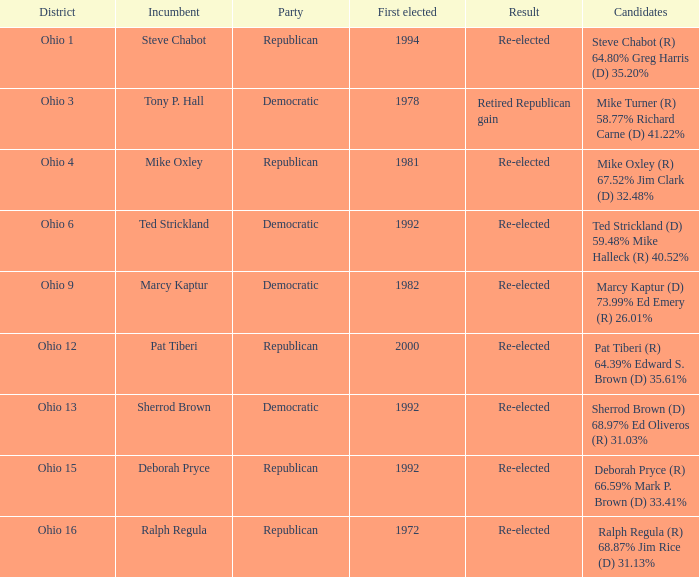Which party was incumbent deborah pryce a member of? Republican. Help me parse the entirety of this table. {'header': ['District', 'Incumbent', 'Party', 'First elected', 'Result', 'Candidates'], 'rows': [['Ohio 1', 'Steve Chabot', 'Republican', '1994', 'Re-elected', 'Steve Chabot (R) 64.80% Greg Harris (D) 35.20%'], ['Ohio 3', 'Tony P. Hall', 'Democratic', '1978', 'Retired Republican gain', 'Mike Turner (R) 58.77% Richard Carne (D) 41.22%'], ['Ohio 4', 'Mike Oxley', 'Republican', '1981', 'Re-elected', 'Mike Oxley (R) 67.52% Jim Clark (D) 32.48%'], ['Ohio 6', 'Ted Strickland', 'Democratic', '1992', 'Re-elected', 'Ted Strickland (D) 59.48% Mike Halleck (R) 40.52%'], ['Ohio 9', 'Marcy Kaptur', 'Democratic', '1982', 'Re-elected', 'Marcy Kaptur (D) 73.99% Ed Emery (R) 26.01%'], ['Ohio 12', 'Pat Tiberi', 'Republican', '2000', 'Re-elected', 'Pat Tiberi (R) 64.39% Edward S. Brown (D) 35.61%'], ['Ohio 13', 'Sherrod Brown', 'Democratic', '1992', 'Re-elected', 'Sherrod Brown (D) 68.97% Ed Oliveros (R) 31.03%'], ['Ohio 15', 'Deborah Pryce', 'Republican', '1992', 'Re-elected', 'Deborah Pryce (R) 66.59% Mark P. Brown (D) 33.41%'], ['Ohio 16', 'Ralph Regula', 'Republican', '1972', 'Re-elected', 'Ralph Regula (R) 68.87% Jim Rice (D) 31.13%']]} 